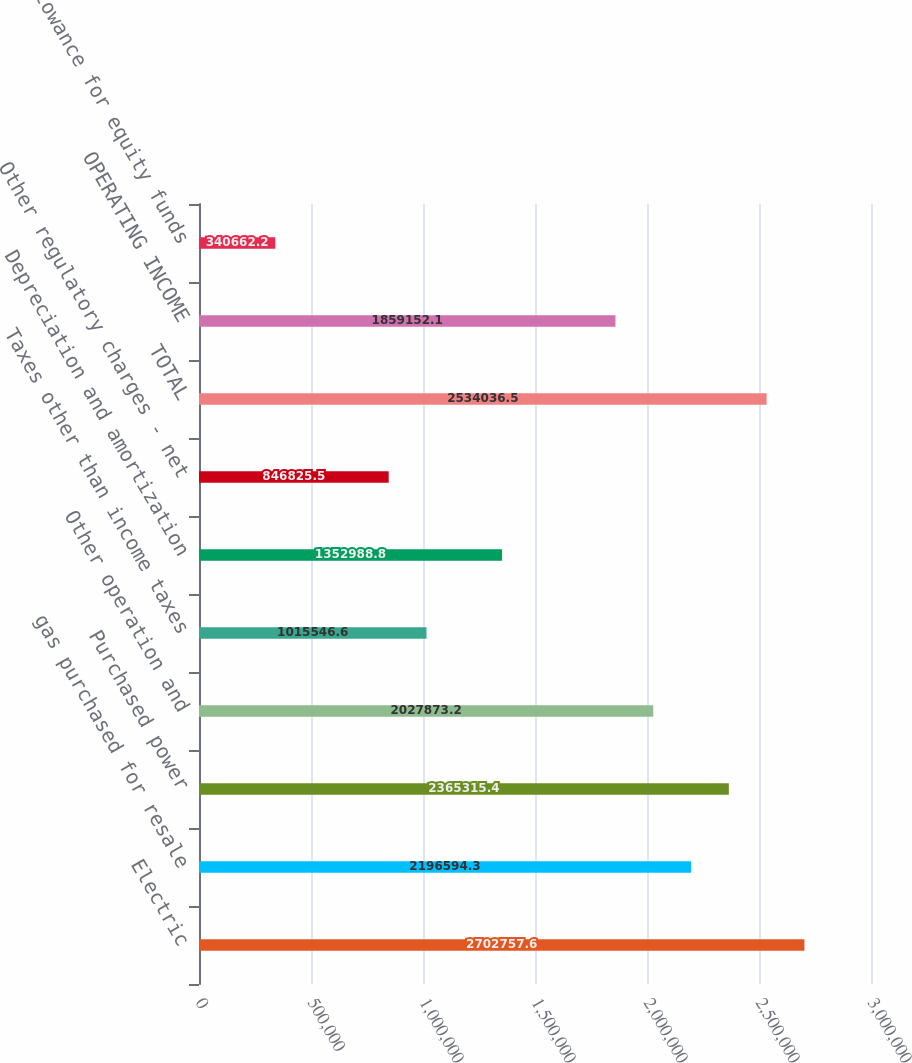Convert chart to OTSL. <chart><loc_0><loc_0><loc_500><loc_500><bar_chart><fcel>Electric<fcel>gas purchased for resale<fcel>Purchased power<fcel>Other operation and<fcel>Taxes other than income taxes<fcel>Depreciation and amortization<fcel>Other regulatory charges - net<fcel>TOTAL<fcel>OPERATING INCOME<fcel>Allowance for equity funds<nl><fcel>2.70276e+06<fcel>2.19659e+06<fcel>2.36532e+06<fcel>2.02787e+06<fcel>1.01555e+06<fcel>1.35299e+06<fcel>846826<fcel>2.53404e+06<fcel>1.85915e+06<fcel>340662<nl></chart> 